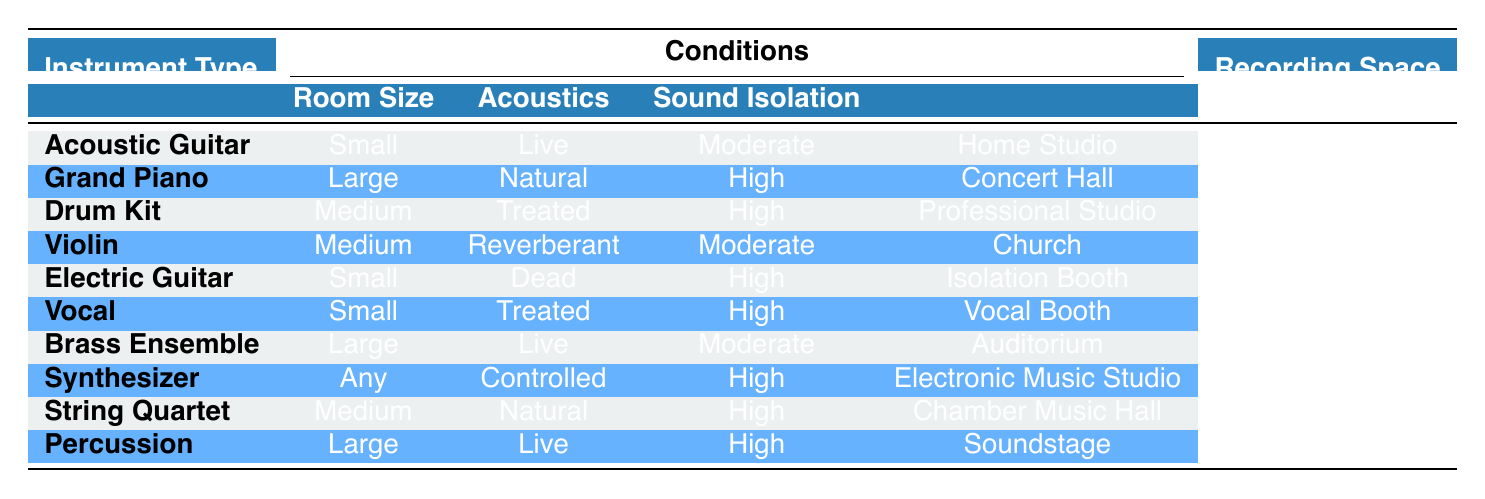What is the recording space for an Acoustic Guitar? According to the table, for an Acoustic Guitar, the corresponding recording space is 'Home Studio' based on the listed conditions of small room size, live acoustics, and moderate sound isolation.
Answer: Home Studio Which instrument type requires a Concert Hall for recording? The table indicates that the Grand Piano is the instrument type that requires a Concert Hall for recording, as it has a large room size, natural acoustics, and high sound isolation.
Answer: Grand Piano How many instruments are recorded in a large room size? The table lists three instruments that are recorded in a large room: Grand Piano, Brass Ensemble, and Percussion. Counting these gives us a total of three instruments recorded in a large room size.
Answer: 3 Is it true that the Vocal recording space is a Vocal Booth? The table confirms that for the Vocal, the recording space is indeed a Vocal Booth, as indicated by the corresponding conditions of small room size, treated acoustics, and high sound isolation.
Answer: Yes What is the recording space for a String Quartet under the given conditions? The table specifies that a String Quartet requires a Chamber Music Hall as the recording space, as it has a medium room size, natural acoustics, and high sound isolation.
Answer: Chamber Music Hall Which instrument types have a high sound isolation condition? Upon reviewing the table, the instrument types with high sound isolation conditions are Grand Piano, Drum Kit, Electric Guitar, Vocal, Synthesizer, and Percussion. Counting these gives six instrument types that satisfy this condition.
Answer: 6 If an Electric Guitar is recorded in an Isolation Booth, what are its conditions? The table shows that the Electric Guitar has the conditions of a small room size, dead acoustics, and high sound isolation when recorded in an Isolation Booth. The solution is derived by looking directly at the row corresponding to the Electric Guitar.
Answer: Small room size, dead acoustics, high sound isolation What is the most viable recording space for a Drum Kit? The table shows that the most viable recording space for a Drum Kit is a Professional Studio, given its medium room size, treated acoustics, and high sound isolation. This can be directly answered by reviewing the row containing information about the Drum Kit.
Answer: Professional Studio 